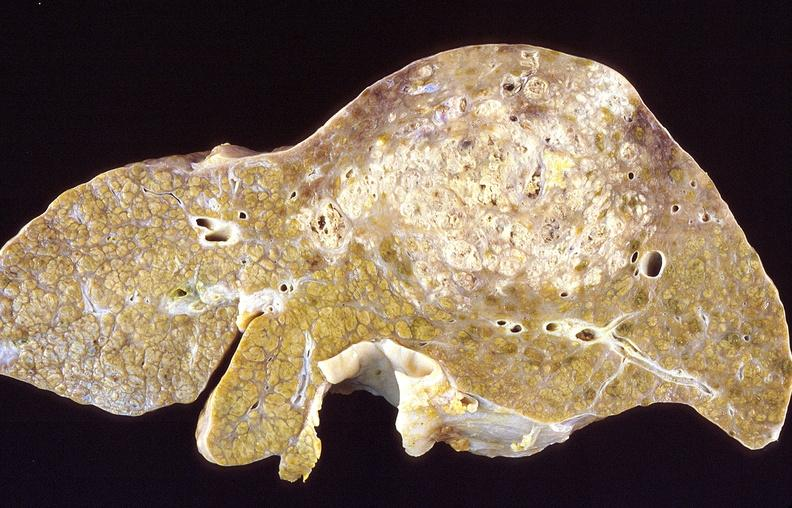s gross photo of tumor in this file present?
Answer the question using a single word or phrase. No 